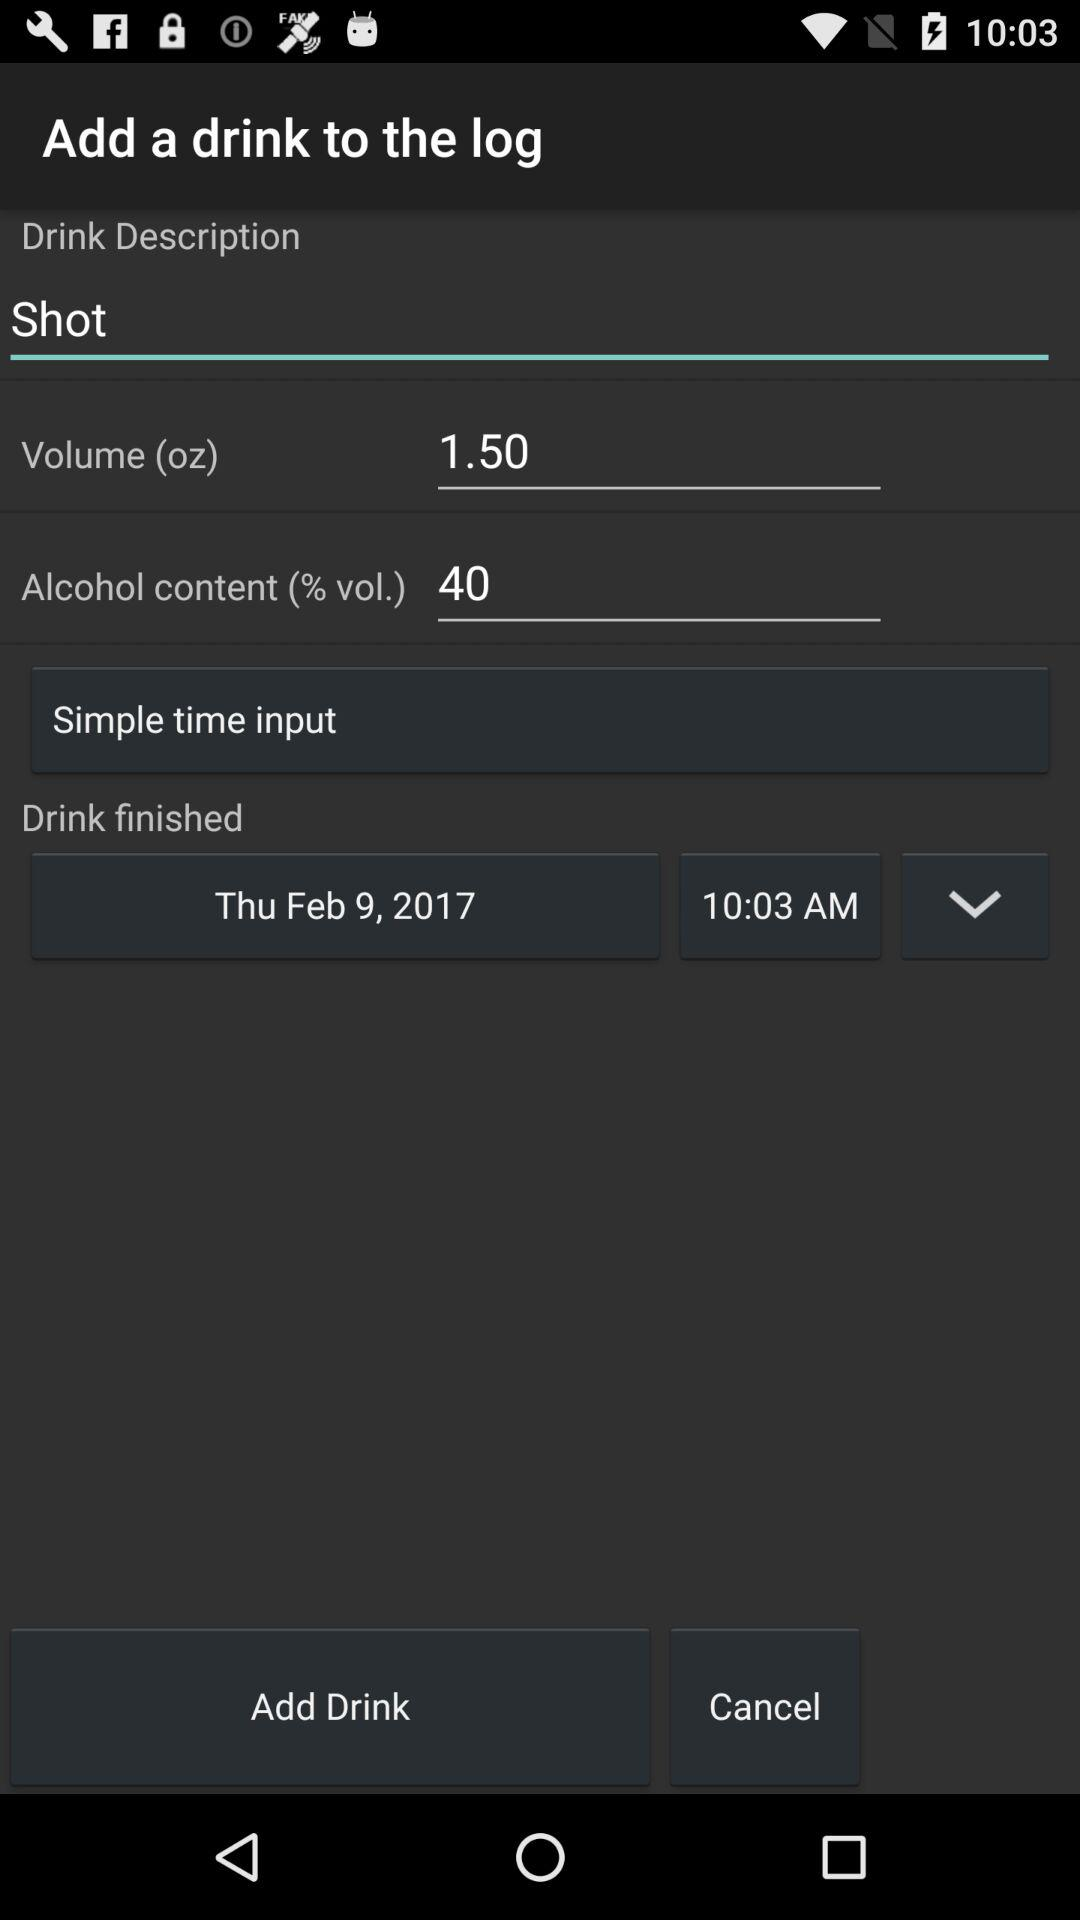What is the drink description? The drink description is "Shot". 